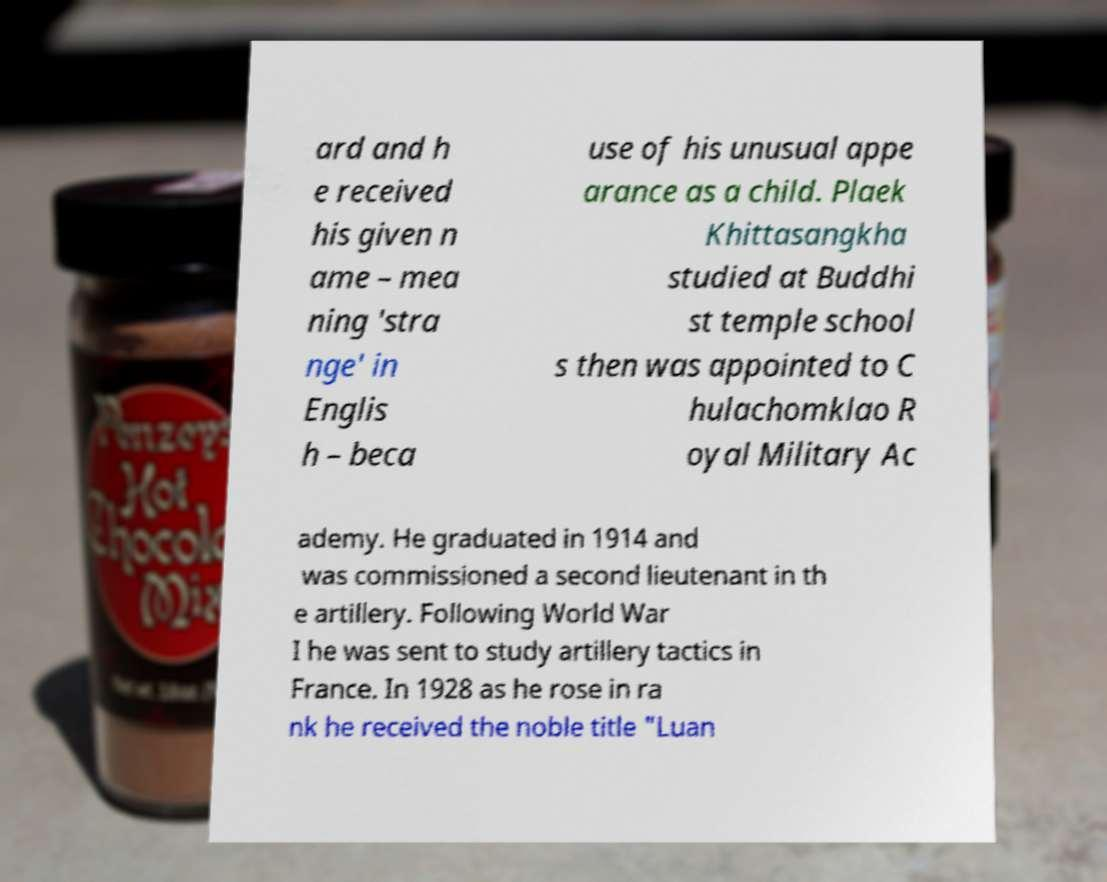I need the written content from this picture converted into text. Can you do that? ard and h e received his given n ame – mea ning 'stra nge' in Englis h – beca use of his unusual appe arance as a child. Plaek Khittasangkha studied at Buddhi st temple school s then was appointed to C hulachomklao R oyal Military Ac ademy. He graduated in 1914 and was commissioned a second lieutenant in th e artillery. Following World War I he was sent to study artillery tactics in France. In 1928 as he rose in ra nk he received the noble title "Luan 